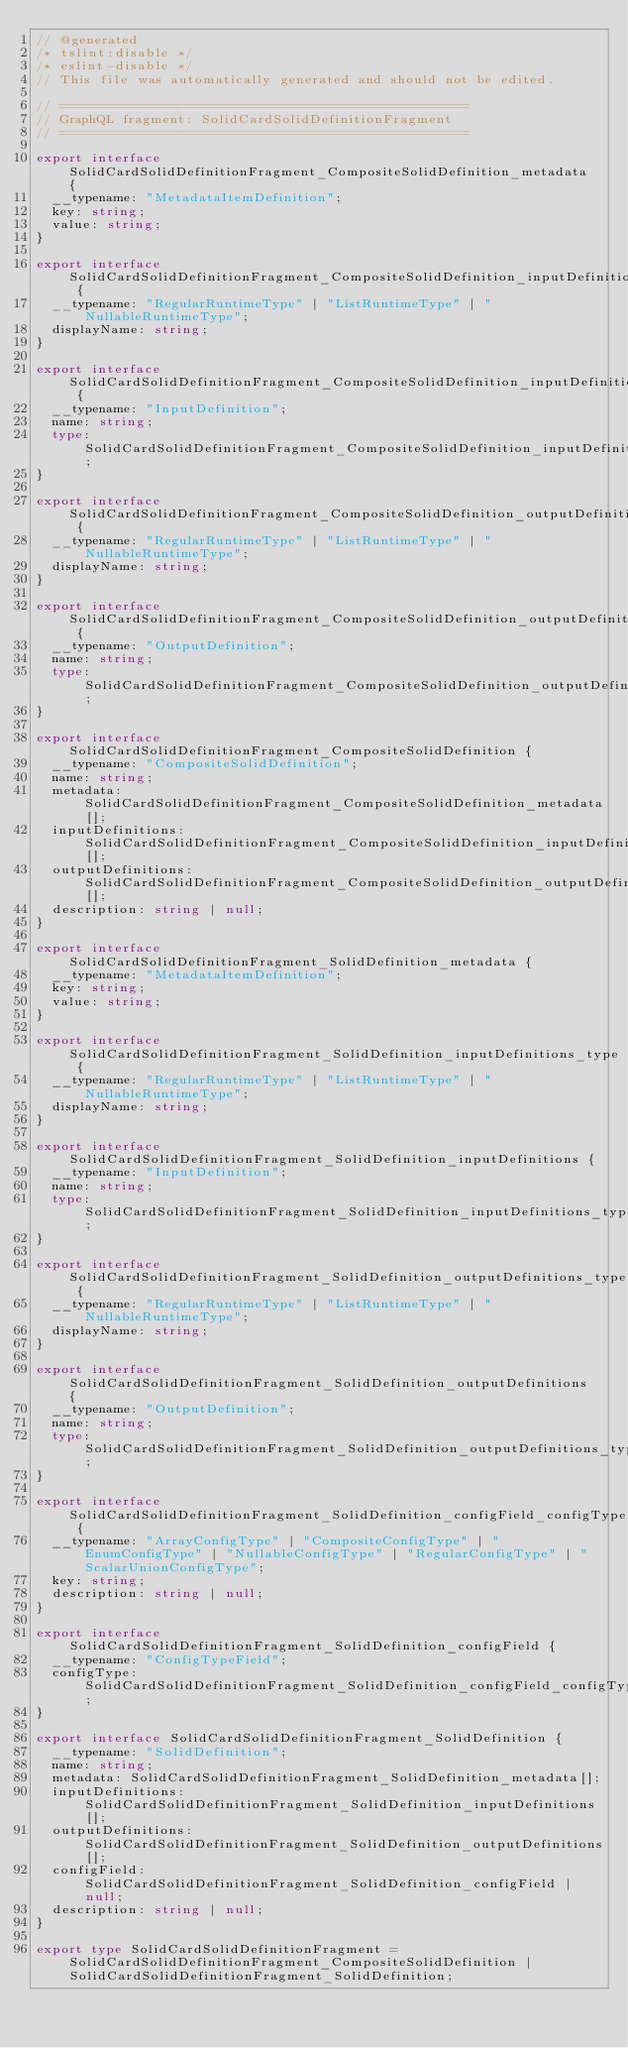<code> <loc_0><loc_0><loc_500><loc_500><_TypeScript_>// @generated
/* tslint:disable */
/* eslint-disable */
// This file was automatically generated and should not be edited.

// ====================================================
// GraphQL fragment: SolidCardSolidDefinitionFragment
// ====================================================

export interface SolidCardSolidDefinitionFragment_CompositeSolidDefinition_metadata {
  __typename: "MetadataItemDefinition";
  key: string;
  value: string;
}

export interface SolidCardSolidDefinitionFragment_CompositeSolidDefinition_inputDefinitions_type {
  __typename: "RegularRuntimeType" | "ListRuntimeType" | "NullableRuntimeType";
  displayName: string;
}

export interface SolidCardSolidDefinitionFragment_CompositeSolidDefinition_inputDefinitions {
  __typename: "InputDefinition";
  name: string;
  type: SolidCardSolidDefinitionFragment_CompositeSolidDefinition_inputDefinitions_type;
}

export interface SolidCardSolidDefinitionFragment_CompositeSolidDefinition_outputDefinitions_type {
  __typename: "RegularRuntimeType" | "ListRuntimeType" | "NullableRuntimeType";
  displayName: string;
}

export interface SolidCardSolidDefinitionFragment_CompositeSolidDefinition_outputDefinitions {
  __typename: "OutputDefinition";
  name: string;
  type: SolidCardSolidDefinitionFragment_CompositeSolidDefinition_outputDefinitions_type;
}

export interface SolidCardSolidDefinitionFragment_CompositeSolidDefinition {
  __typename: "CompositeSolidDefinition";
  name: string;
  metadata: SolidCardSolidDefinitionFragment_CompositeSolidDefinition_metadata[];
  inputDefinitions: SolidCardSolidDefinitionFragment_CompositeSolidDefinition_inputDefinitions[];
  outputDefinitions: SolidCardSolidDefinitionFragment_CompositeSolidDefinition_outputDefinitions[];
  description: string | null;
}

export interface SolidCardSolidDefinitionFragment_SolidDefinition_metadata {
  __typename: "MetadataItemDefinition";
  key: string;
  value: string;
}

export interface SolidCardSolidDefinitionFragment_SolidDefinition_inputDefinitions_type {
  __typename: "RegularRuntimeType" | "ListRuntimeType" | "NullableRuntimeType";
  displayName: string;
}

export interface SolidCardSolidDefinitionFragment_SolidDefinition_inputDefinitions {
  __typename: "InputDefinition";
  name: string;
  type: SolidCardSolidDefinitionFragment_SolidDefinition_inputDefinitions_type;
}

export interface SolidCardSolidDefinitionFragment_SolidDefinition_outputDefinitions_type {
  __typename: "RegularRuntimeType" | "ListRuntimeType" | "NullableRuntimeType";
  displayName: string;
}

export interface SolidCardSolidDefinitionFragment_SolidDefinition_outputDefinitions {
  __typename: "OutputDefinition";
  name: string;
  type: SolidCardSolidDefinitionFragment_SolidDefinition_outputDefinitions_type;
}

export interface SolidCardSolidDefinitionFragment_SolidDefinition_configField_configType {
  __typename: "ArrayConfigType" | "CompositeConfigType" | "EnumConfigType" | "NullableConfigType" | "RegularConfigType" | "ScalarUnionConfigType";
  key: string;
  description: string | null;
}

export interface SolidCardSolidDefinitionFragment_SolidDefinition_configField {
  __typename: "ConfigTypeField";
  configType: SolidCardSolidDefinitionFragment_SolidDefinition_configField_configType;
}

export interface SolidCardSolidDefinitionFragment_SolidDefinition {
  __typename: "SolidDefinition";
  name: string;
  metadata: SolidCardSolidDefinitionFragment_SolidDefinition_metadata[];
  inputDefinitions: SolidCardSolidDefinitionFragment_SolidDefinition_inputDefinitions[];
  outputDefinitions: SolidCardSolidDefinitionFragment_SolidDefinition_outputDefinitions[];
  configField: SolidCardSolidDefinitionFragment_SolidDefinition_configField | null;
  description: string | null;
}

export type SolidCardSolidDefinitionFragment = SolidCardSolidDefinitionFragment_CompositeSolidDefinition | SolidCardSolidDefinitionFragment_SolidDefinition;
</code> 